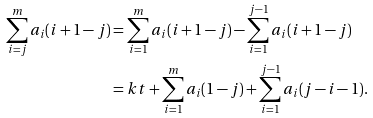<formula> <loc_0><loc_0><loc_500><loc_500>\sum _ { i = j } ^ { m } a _ { i } ( i + 1 - j ) & = \sum _ { i = 1 } ^ { m } a _ { i } ( i + 1 - j ) - \sum _ { i = 1 } ^ { j - 1 } a _ { i } ( i + 1 - j ) \\ & = k t + \sum _ { i = 1 } ^ { m } a _ { i } ( 1 - j ) + \sum _ { i = 1 } ^ { j - 1 } a _ { i } ( j - i - 1 ) .</formula> 